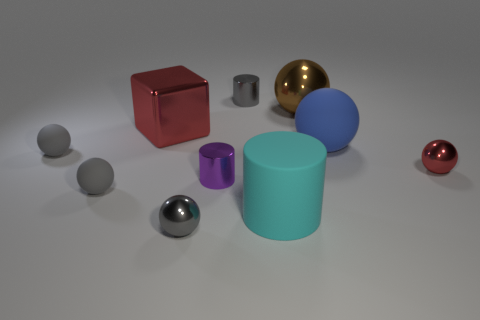Describe the textures of the objects visible in the image. The objects in the image display a variety of textures. The cube and the metallic spheres have a smooth, reflective surface, while the cylinders appear to have a more matte finish. The variations in texture contribute to the visual interest of the scene. 